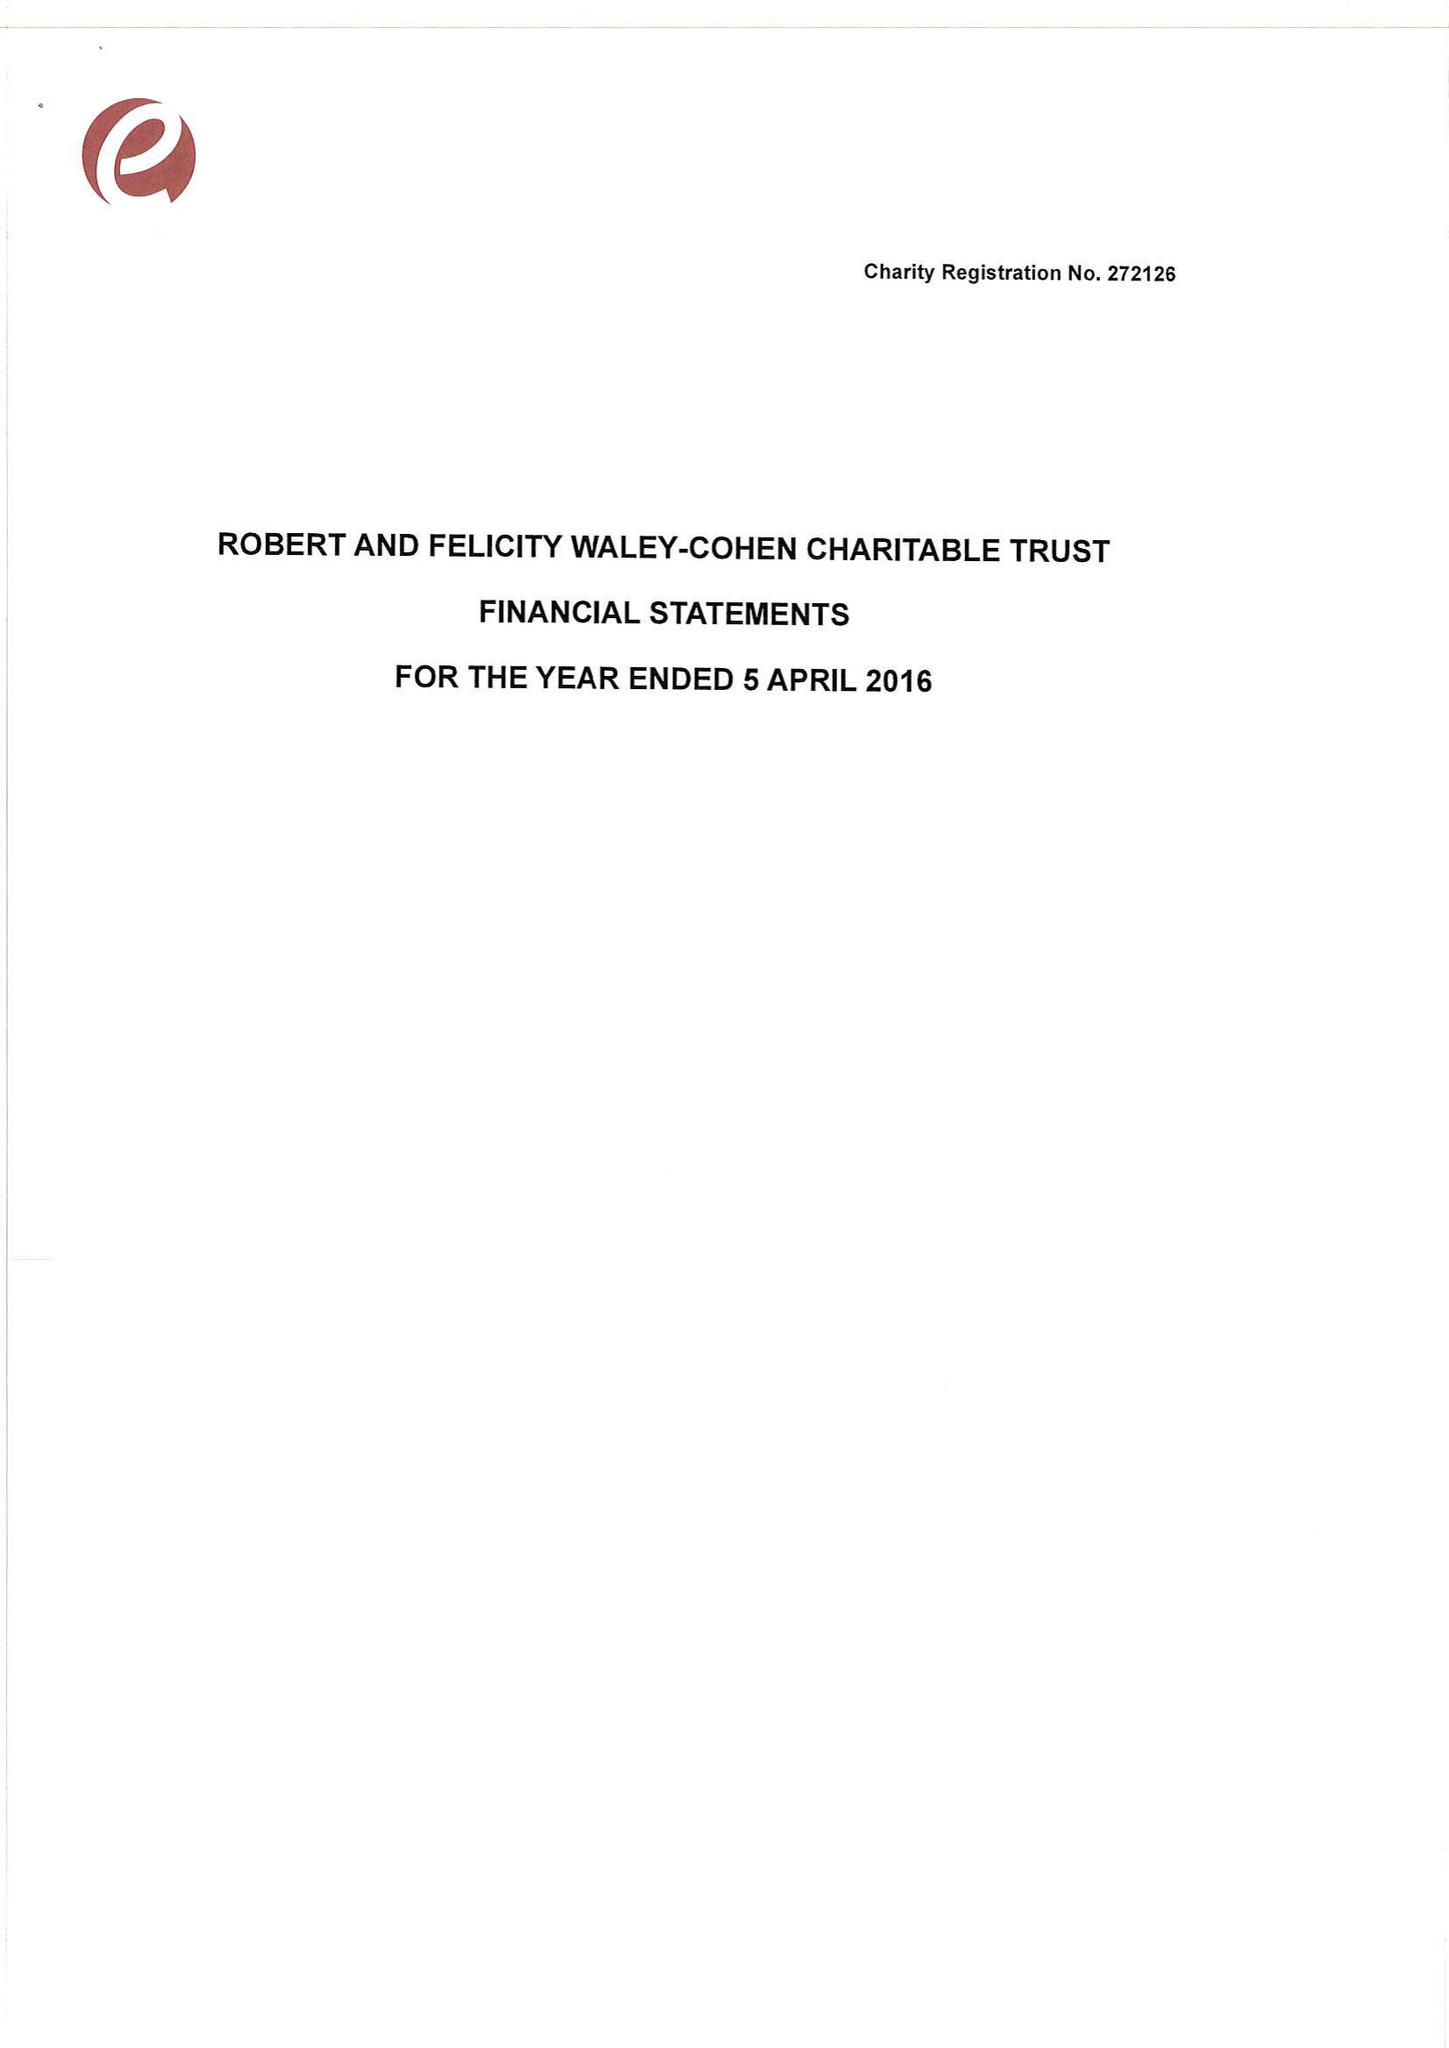What is the value for the spending_annually_in_british_pounds?
Answer the question using a single word or phrase. 173852.00 